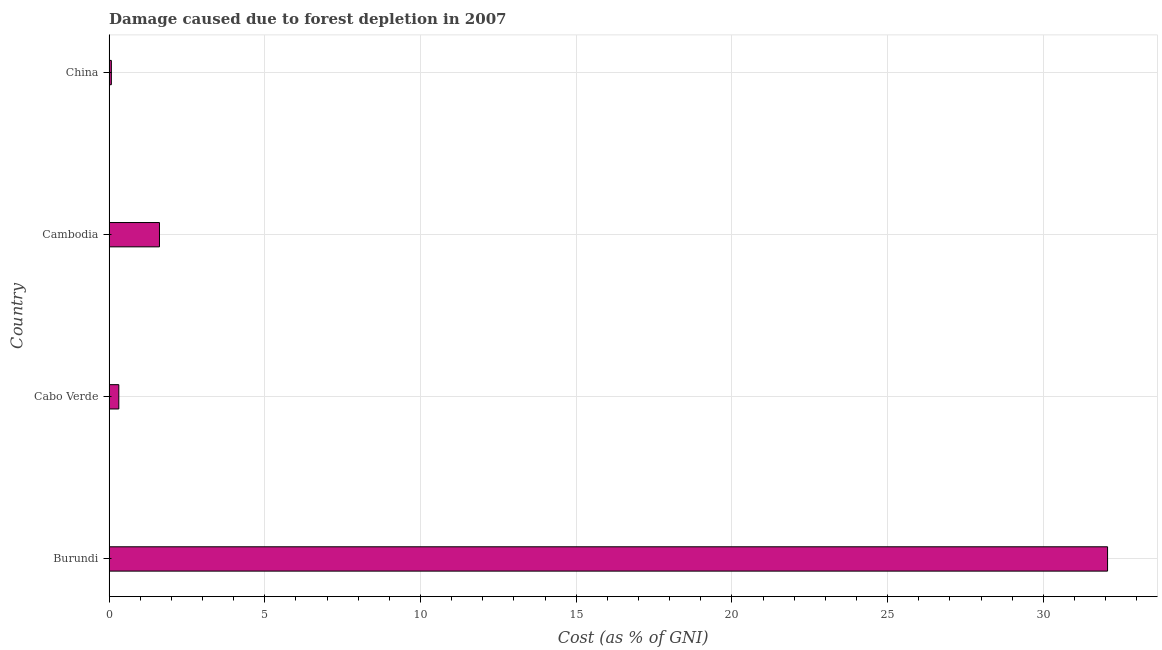Does the graph contain any zero values?
Your response must be concise. No. Does the graph contain grids?
Offer a very short reply. Yes. What is the title of the graph?
Your answer should be very brief. Damage caused due to forest depletion in 2007. What is the label or title of the X-axis?
Your answer should be compact. Cost (as % of GNI). What is the label or title of the Y-axis?
Provide a succinct answer. Country. What is the damage caused due to forest depletion in Burundi?
Your response must be concise. 32.06. Across all countries, what is the maximum damage caused due to forest depletion?
Give a very brief answer. 32.06. Across all countries, what is the minimum damage caused due to forest depletion?
Ensure brevity in your answer.  0.07. In which country was the damage caused due to forest depletion maximum?
Your answer should be compact. Burundi. In which country was the damage caused due to forest depletion minimum?
Provide a short and direct response. China. What is the sum of the damage caused due to forest depletion?
Offer a terse response. 34.07. What is the difference between the damage caused due to forest depletion in Cabo Verde and China?
Ensure brevity in your answer.  0.24. What is the average damage caused due to forest depletion per country?
Keep it short and to the point. 8.52. What is the median damage caused due to forest depletion?
Your answer should be compact. 0.97. What is the ratio of the damage caused due to forest depletion in Burundi to that in China?
Keep it short and to the point. 436.98. What is the difference between the highest and the second highest damage caused due to forest depletion?
Give a very brief answer. 30.44. Is the sum of the damage caused due to forest depletion in Burundi and Cambodia greater than the maximum damage caused due to forest depletion across all countries?
Your answer should be very brief. Yes. What is the difference between the highest and the lowest damage caused due to forest depletion?
Make the answer very short. 31.99. In how many countries, is the damage caused due to forest depletion greater than the average damage caused due to forest depletion taken over all countries?
Offer a terse response. 1. How many countries are there in the graph?
Your answer should be very brief. 4. What is the difference between two consecutive major ticks on the X-axis?
Give a very brief answer. 5. What is the Cost (as % of GNI) of Burundi?
Provide a succinct answer. 32.06. What is the Cost (as % of GNI) of Cabo Verde?
Ensure brevity in your answer.  0.31. What is the Cost (as % of GNI) in Cambodia?
Keep it short and to the point. 1.62. What is the Cost (as % of GNI) of China?
Your answer should be compact. 0.07. What is the difference between the Cost (as % of GNI) in Burundi and Cabo Verde?
Offer a very short reply. 31.75. What is the difference between the Cost (as % of GNI) in Burundi and Cambodia?
Keep it short and to the point. 30.44. What is the difference between the Cost (as % of GNI) in Burundi and China?
Your answer should be compact. 31.99. What is the difference between the Cost (as % of GNI) in Cabo Verde and Cambodia?
Make the answer very short. -1.31. What is the difference between the Cost (as % of GNI) in Cabo Verde and China?
Ensure brevity in your answer.  0.24. What is the difference between the Cost (as % of GNI) in Cambodia and China?
Your answer should be compact. 1.55. What is the ratio of the Cost (as % of GNI) in Burundi to that in Cabo Verde?
Offer a terse response. 102.4. What is the ratio of the Cost (as % of GNI) in Burundi to that in Cambodia?
Your response must be concise. 19.81. What is the ratio of the Cost (as % of GNI) in Burundi to that in China?
Provide a short and direct response. 436.98. What is the ratio of the Cost (as % of GNI) in Cabo Verde to that in Cambodia?
Make the answer very short. 0.19. What is the ratio of the Cost (as % of GNI) in Cabo Verde to that in China?
Offer a very short reply. 4.27. What is the ratio of the Cost (as % of GNI) in Cambodia to that in China?
Give a very brief answer. 22.06. 